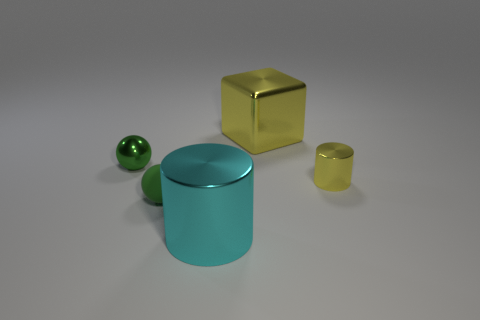Add 2 metallic cylinders. How many objects exist? 7 Subtract all spheres. How many objects are left? 3 Subtract 0 blue cylinders. How many objects are left? 5 Subtract all green metal things. Subtract all big cyan objects. How many objects are left? 3 Add 1 green metal things. How many green metal things are left? 2 Add 5 small matte objects. How many small matte objects exist? 6 